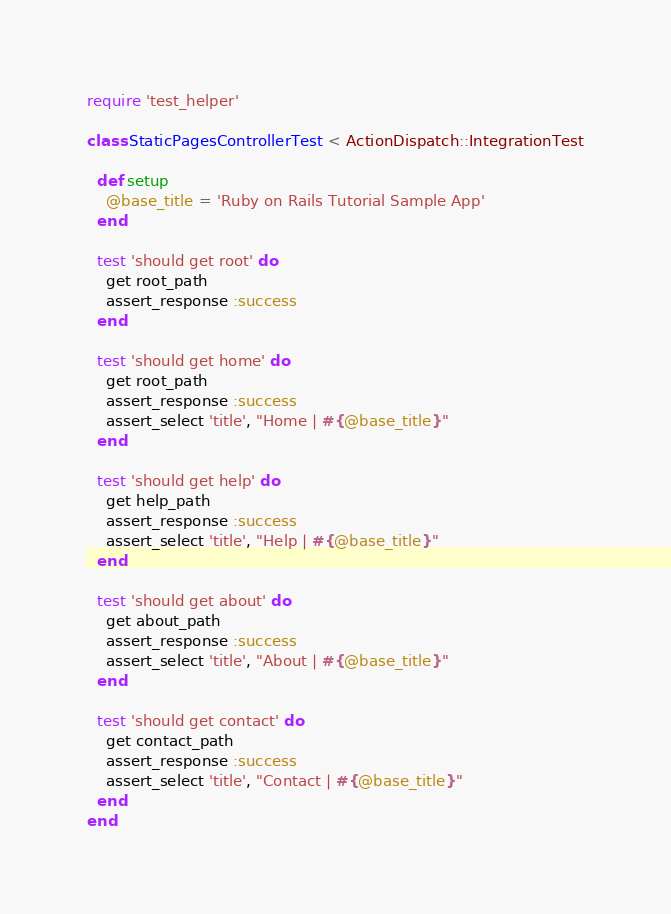Convert code to text. <code><loc_0><loc_0><loc_500><loc_500><_Ruby_>require 'test_helper'

class StaticPagesControllerTest < ActionDispatch::IntegrationTest

  def setup 
  	@base_title = 'Ruby on Rails Tutorial Sample App'
  end
  
  test 'should get root' do
    get root_path
    assert_response :success
  end

  test 'should get home' do
    get root_path
    assert_response :success
    assert_select 'title', "Home | #{@base_title}"
  end

  test 'should get help' do
    get help_path
    assert_response :success
    assert_select 'title', "Help | #{@base_title}"
  end

  test 'should get about' do
    get about_path
    assert_response :success
    assert_select 'title', "About | #{@base_title}"
  end
  
  test 'should get contact' do
  	get contact_path
  	assert_response :success
  	assert_select 'title', "Contact | #{@base_title}"
  end
end
</code> 